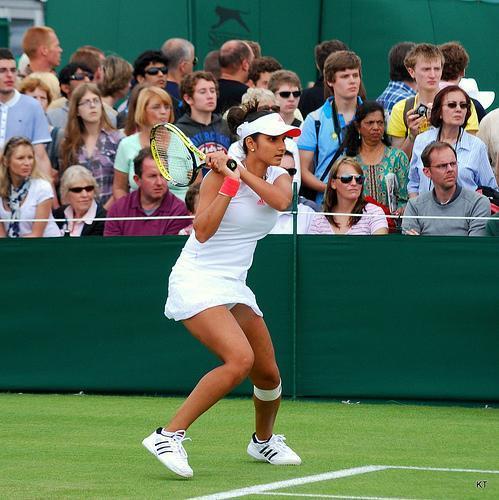How many rackets?
Give a very brief answer. 1. 